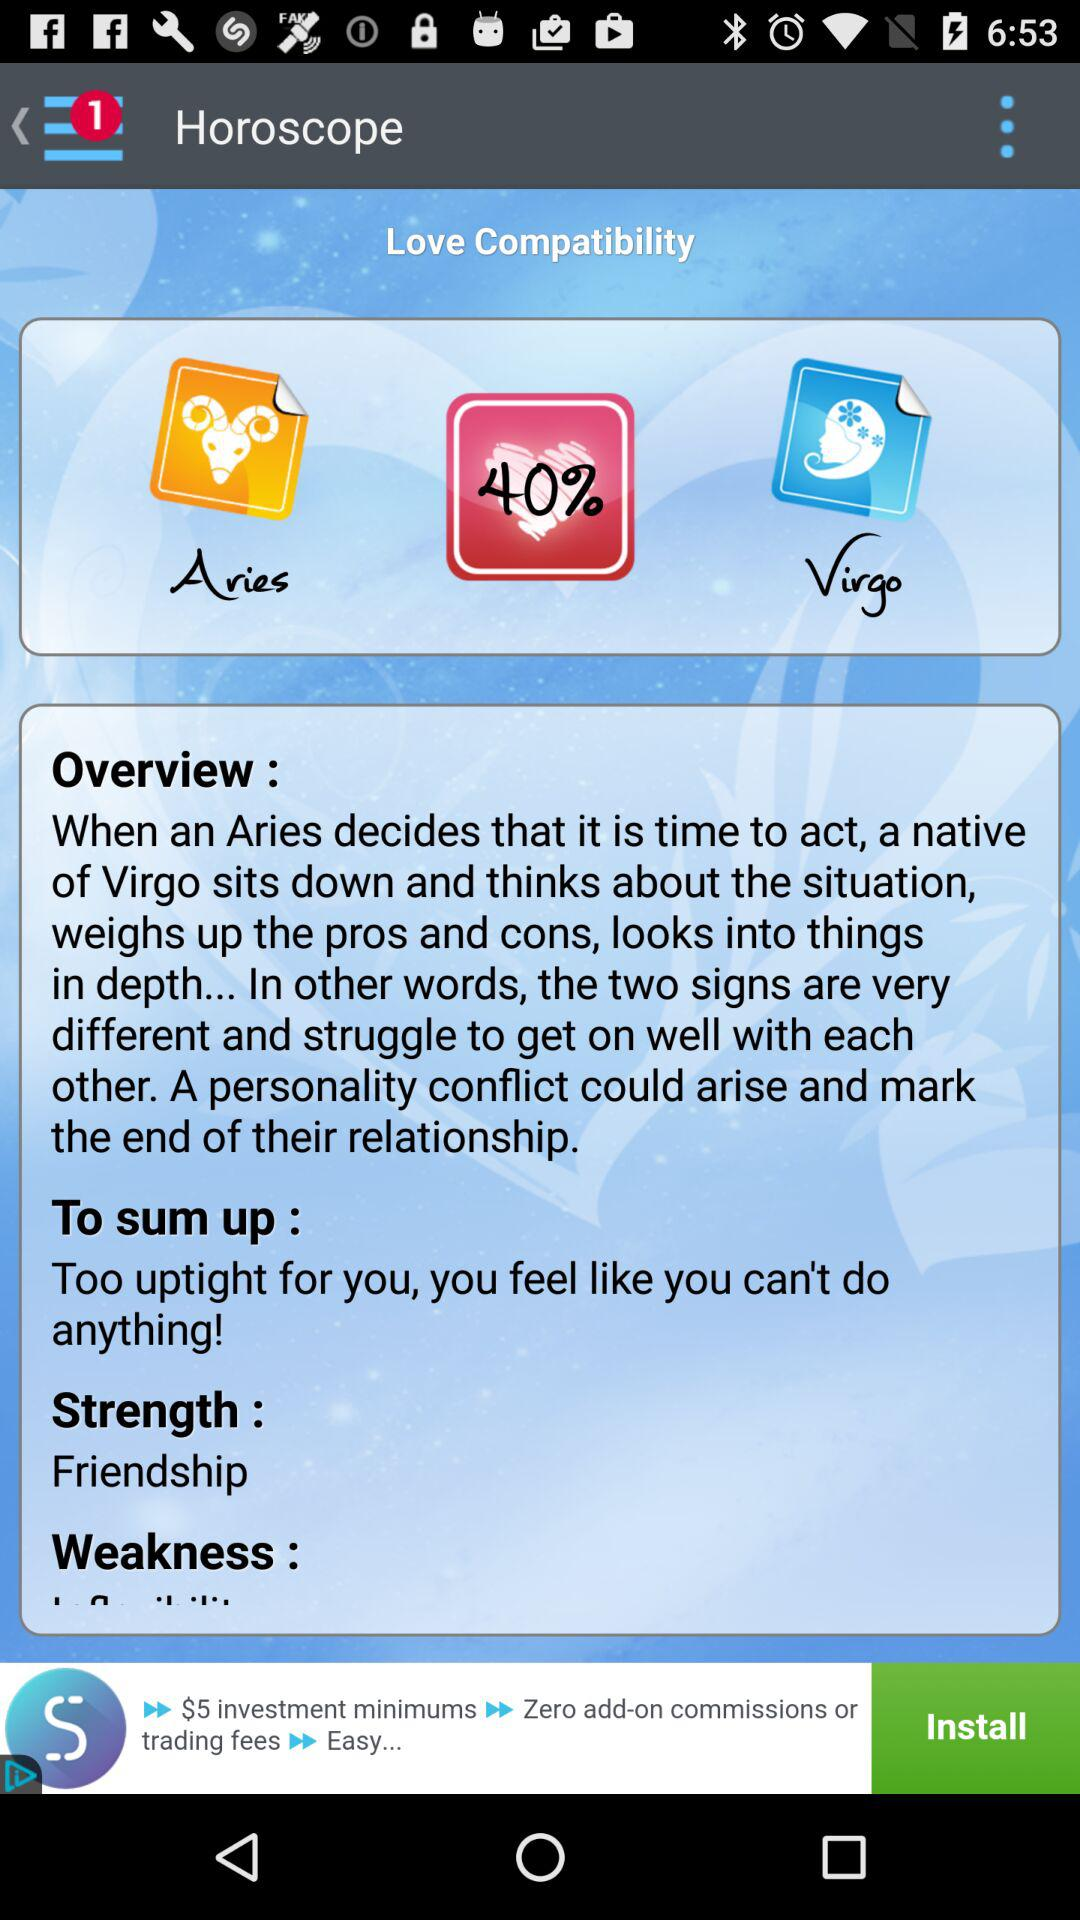What is the strength? The strength is "Friendship". 